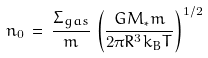Convert formula to latex. <formula><loc_0><loc_0><loc_500><loc_500>n _ { 0 } \, = \, \frac { { \Sigma } _ { g a s } } { m } \, \left ( \frac { G M _ { * } m } { 2 { \pi } R ^ { 3 } k _ { B } T } \right ) ^ { 1 / 2 }</formula> 